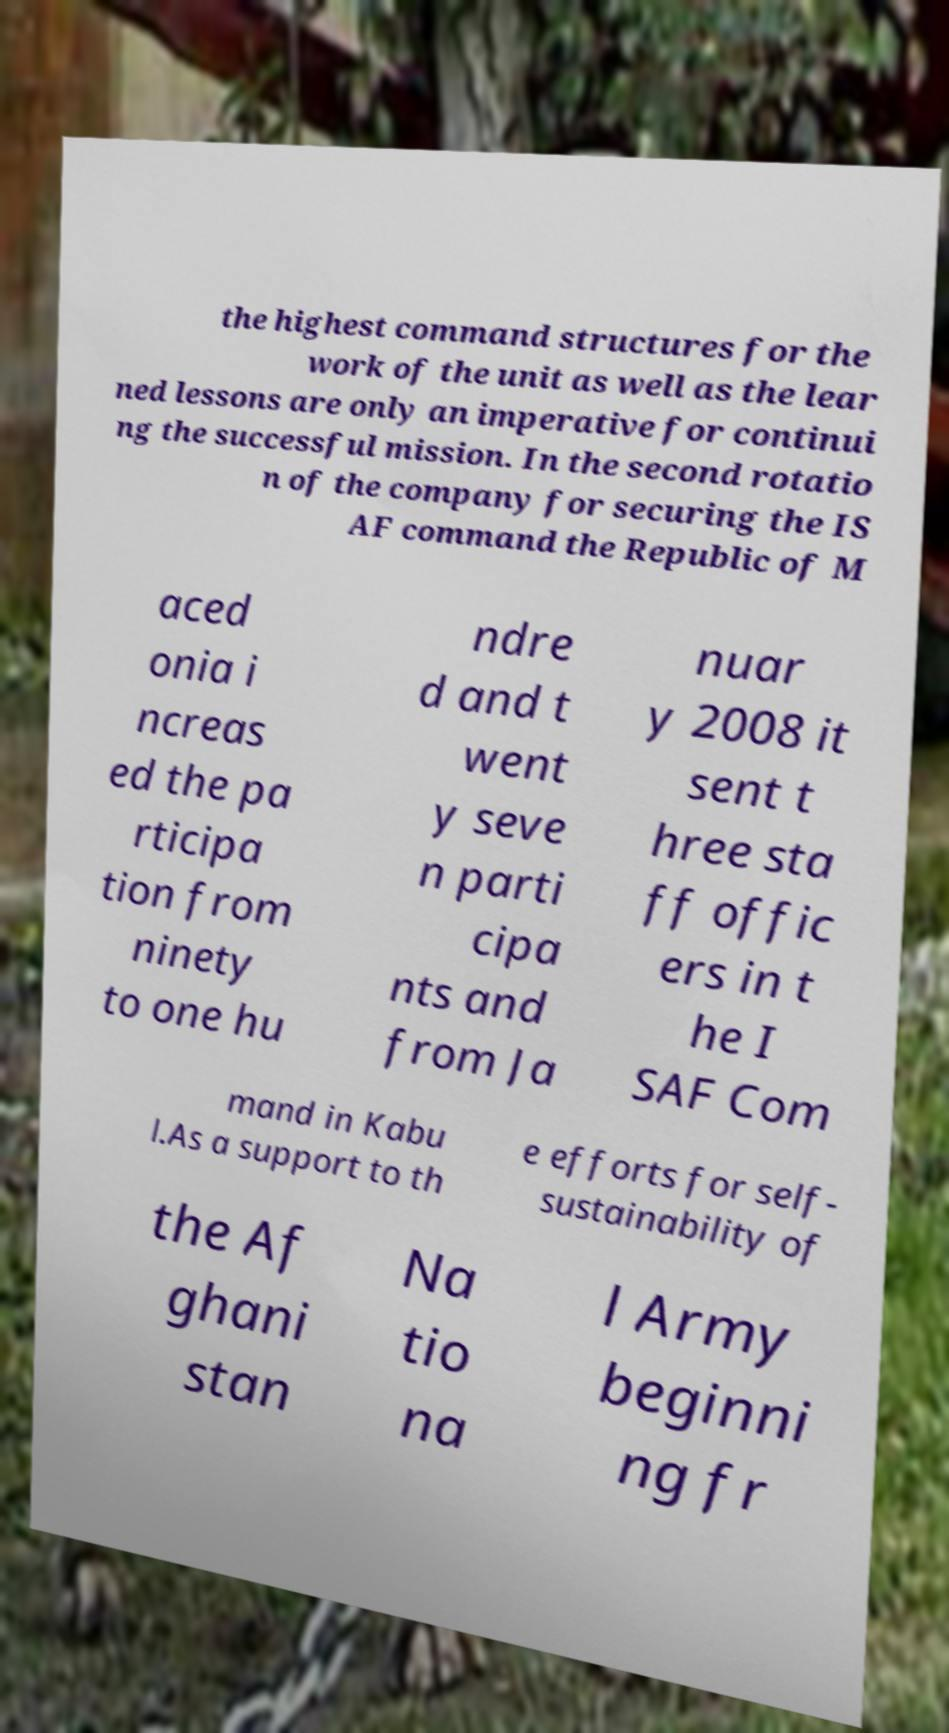Please identify and transcribe the text found in this image. the highest command structures for the work of the unit as well as the lear ned lessons are only an imperative for continui ng the successful mission. In the second rotatio n of the company for securing the IS AF command the Republic of M aced onia i ncreas ed the pa rticipa tion from ninety to one hu ndre d and t went y seve n parti cipa nts and from Ja nuar y 2008 it sent t hree sta ff offic ers in t he I SAF Com mand in Kabu l.As a support to th e efforts for self- sustainability of the Af ghani stan Na tio na l Army beginni ng fr 